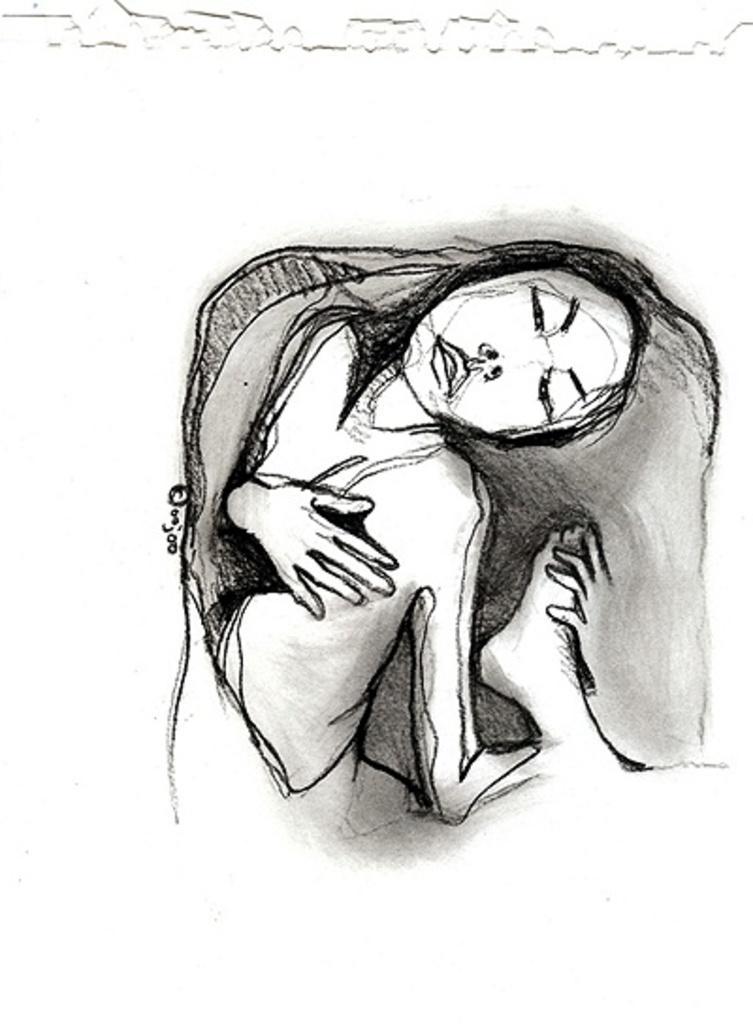In one or two sentences, can you explain what this image depicts? This image is drawing of a woman and the background is white. 